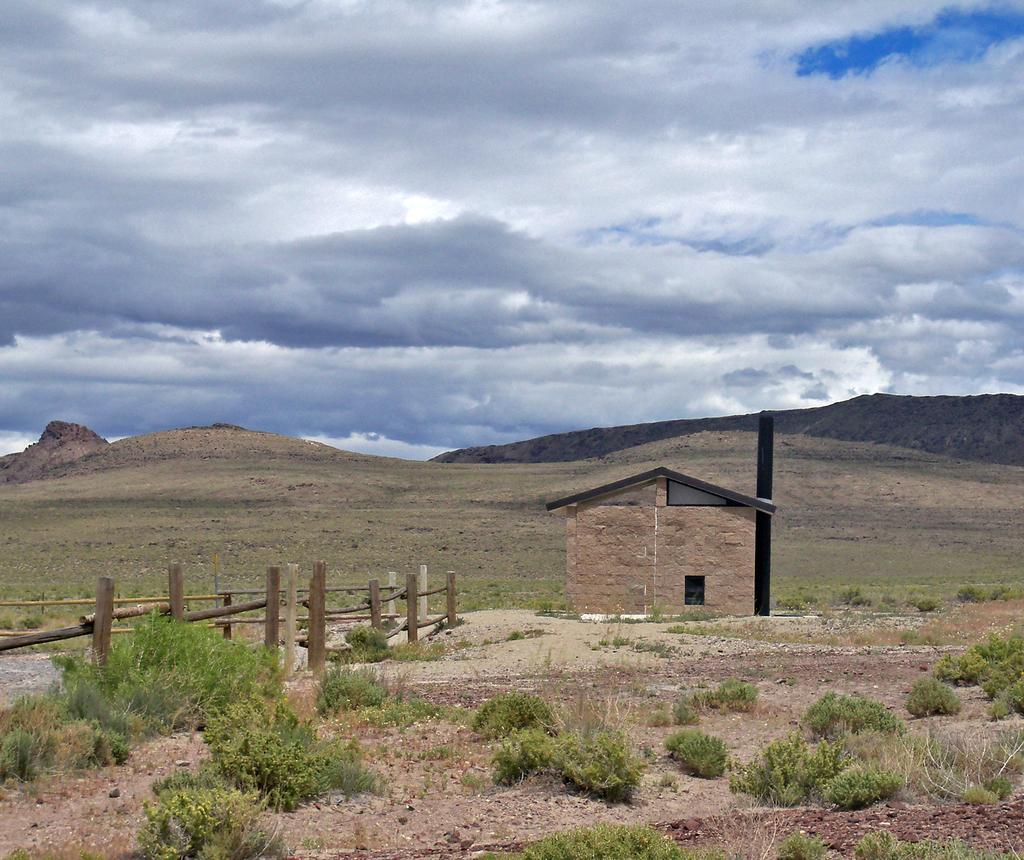How would you summarize this image in a sentence or two? At the bottom of the image there are plants. There is wooden fencing. There is a house. In the background of the image there are mountains, sky and clouds. 